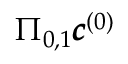<formula> <loc_0><loc_0><loc_500><loc_500>\Pi _ { 0 , 1 } \pm b { c } ^ { ( 0 ) }</formula> 